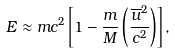<formula> <loc_0><loc_0><loc_500><loc_500>E \approx m c ^ { 2 } \left [ 1 - \frac { m } { M } \left ( \frac { { \overline { u } } ^ { 2 } } { c ^ { 2 } } \right ) \right ] ,</formula> 